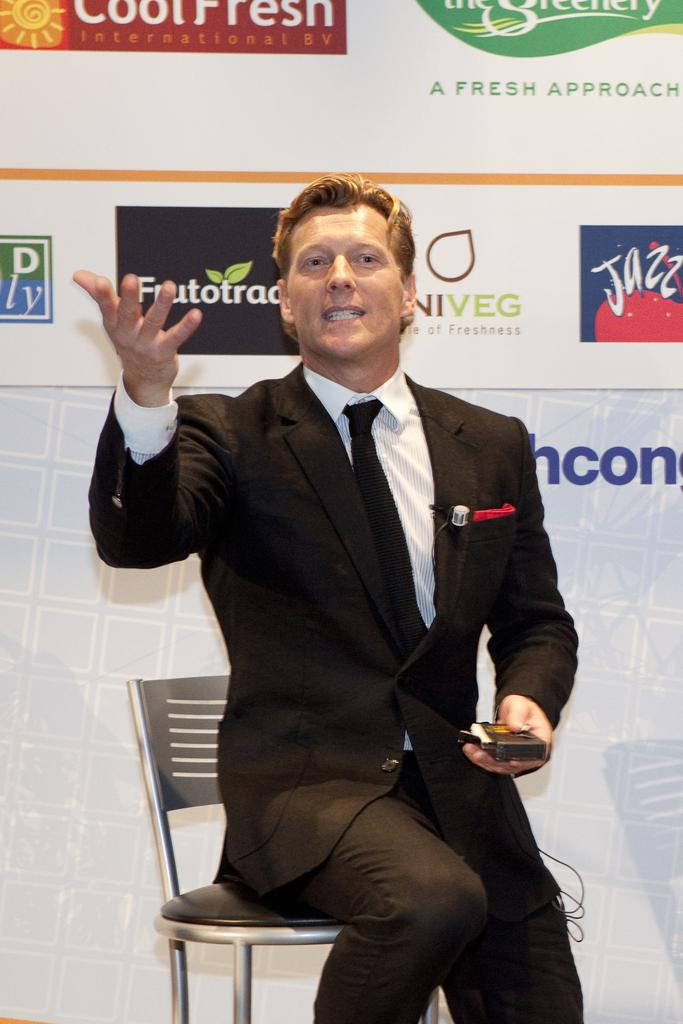Who is present in the image? There is a man in the image. What is the man wearing? The man is wearing a suit. What is the man sitting on? The man is sitting on a silver-colored chair. What is the man holding in the image? The man is holding a box. What can be seen in the background of the image? There are banners in the background of the image. What type of pocket can be seen on the stage in the image? There is no stage or pocket present in the image. How does the man reach the end of the stage in the image? There is no stage or end in the image; the man is sitting on a silver-colored chair. 